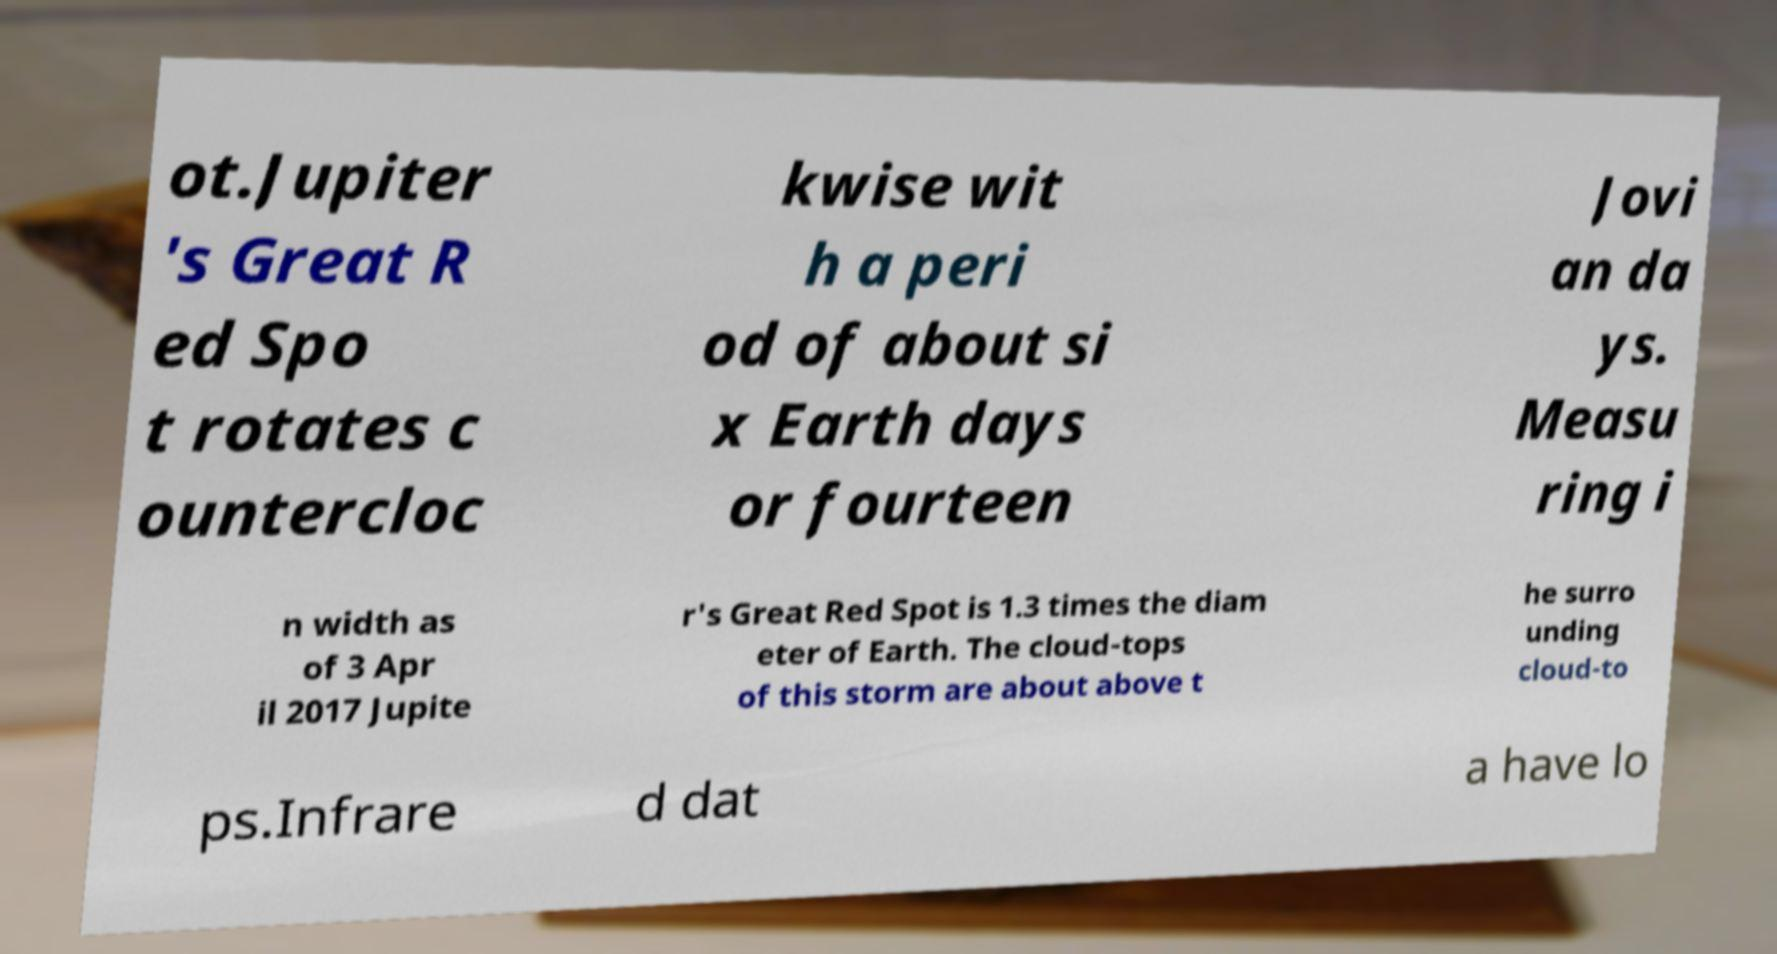Could you assist in decoding the text presented in this image and type it out clearly? ot.Jupiter 's Great R ed Spo t rotates c ountercloc kwise wit h a peri od of about si x Earth days or fourteen Jovi an da ys. Measu ring i n width as of 3 Apr il 2017 Jupite r's Great Red Spot is 1.3 times the diam eter of Earth. The cloud-tops of this storm are about above t he surro unding cloud-to ps.Infrare d dat a have lo 